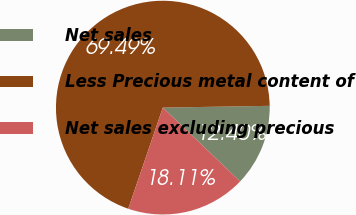Convert chart. <chart><loc_0><loc_0><loc_500><loc_500><pie_chart><fcel>Net sales<fcel>Less Precious metal content of<fcel>Net sales excluding precious<nl><fcel>12.4%<fcel>69.5%<fcel>18.11%<nl></chart> 